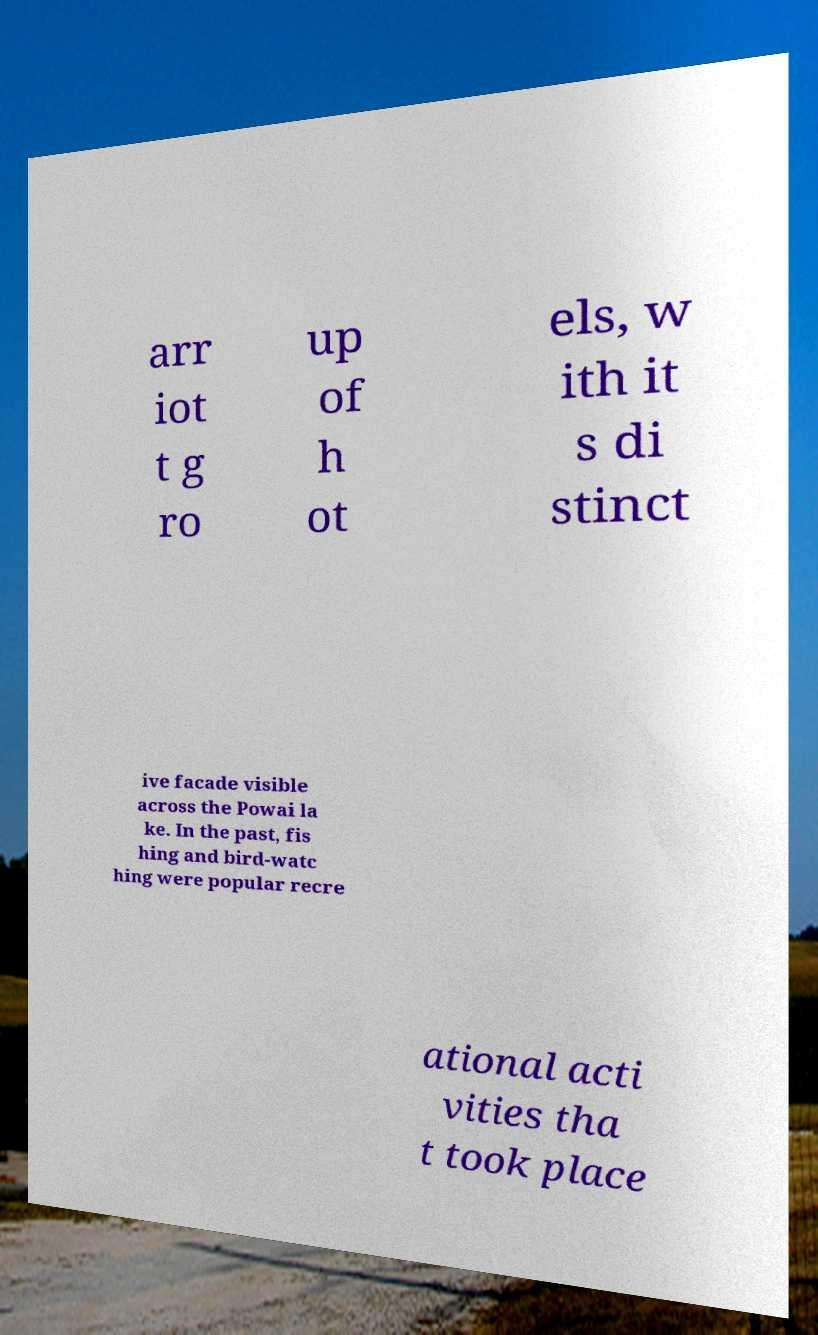I need the written content from this picture converted into text. Can you do that? arr iot t g ro up of h ot els, w ith it s di stinct ive facade visible across the Powai la ke. In the past, fis hing and bird-watc hing were popular recre ational acti vities tha t took place 